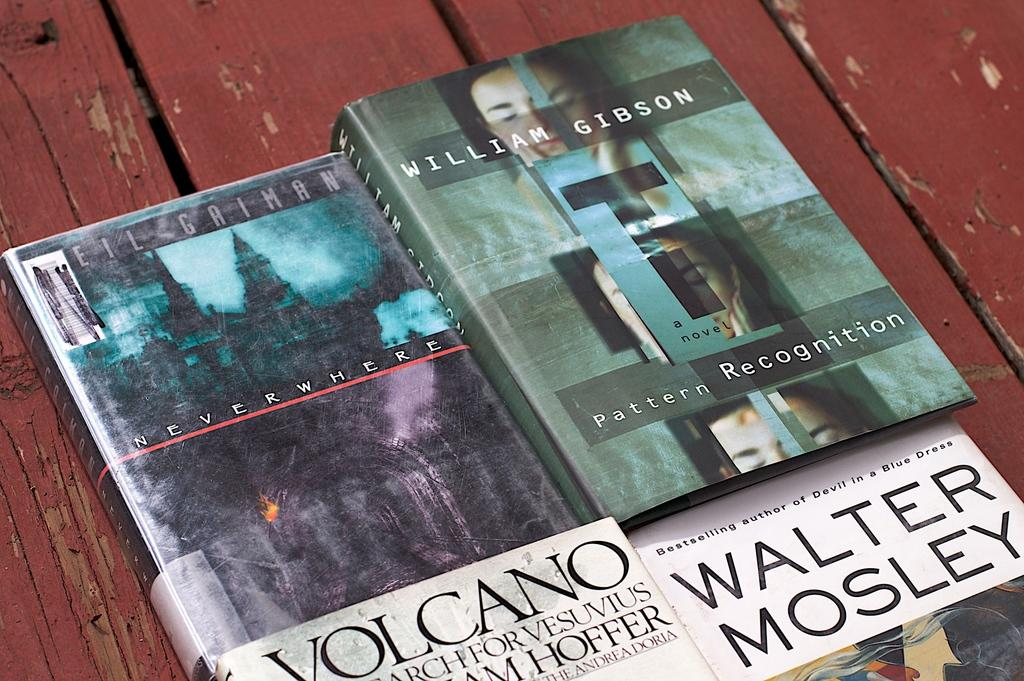<image>
Provide a brief description of the given image. Four books, one being written by William Gibson, are laying on top of red painted wood. 